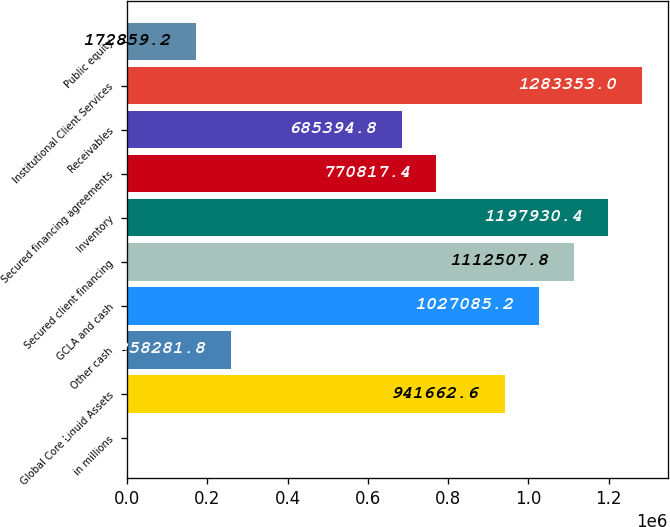Convert chart to OTSL. <chart><loc_0><loc_0><loc_500><loc_500><bar_chart><fcel>in millions<fcel>Global Core Liquid Assets<fcel>Other cash<fcel>GCLA and cash<fcel>Secured client financing<fcel>Inventory<fcel>Secured financing agreements<fcel>Receivables<fcel>Institutional Client Services<fcel>Public equity<nl><fcel>2014<fcel>941663<fcel>258282<fcel>1.02709e+06<fcel>1.11251e+06<fcel>1.19793e+06<fcel>770817<fcel>685395<fcel>1.28335e+06<fcel>172859<nl></chart> 